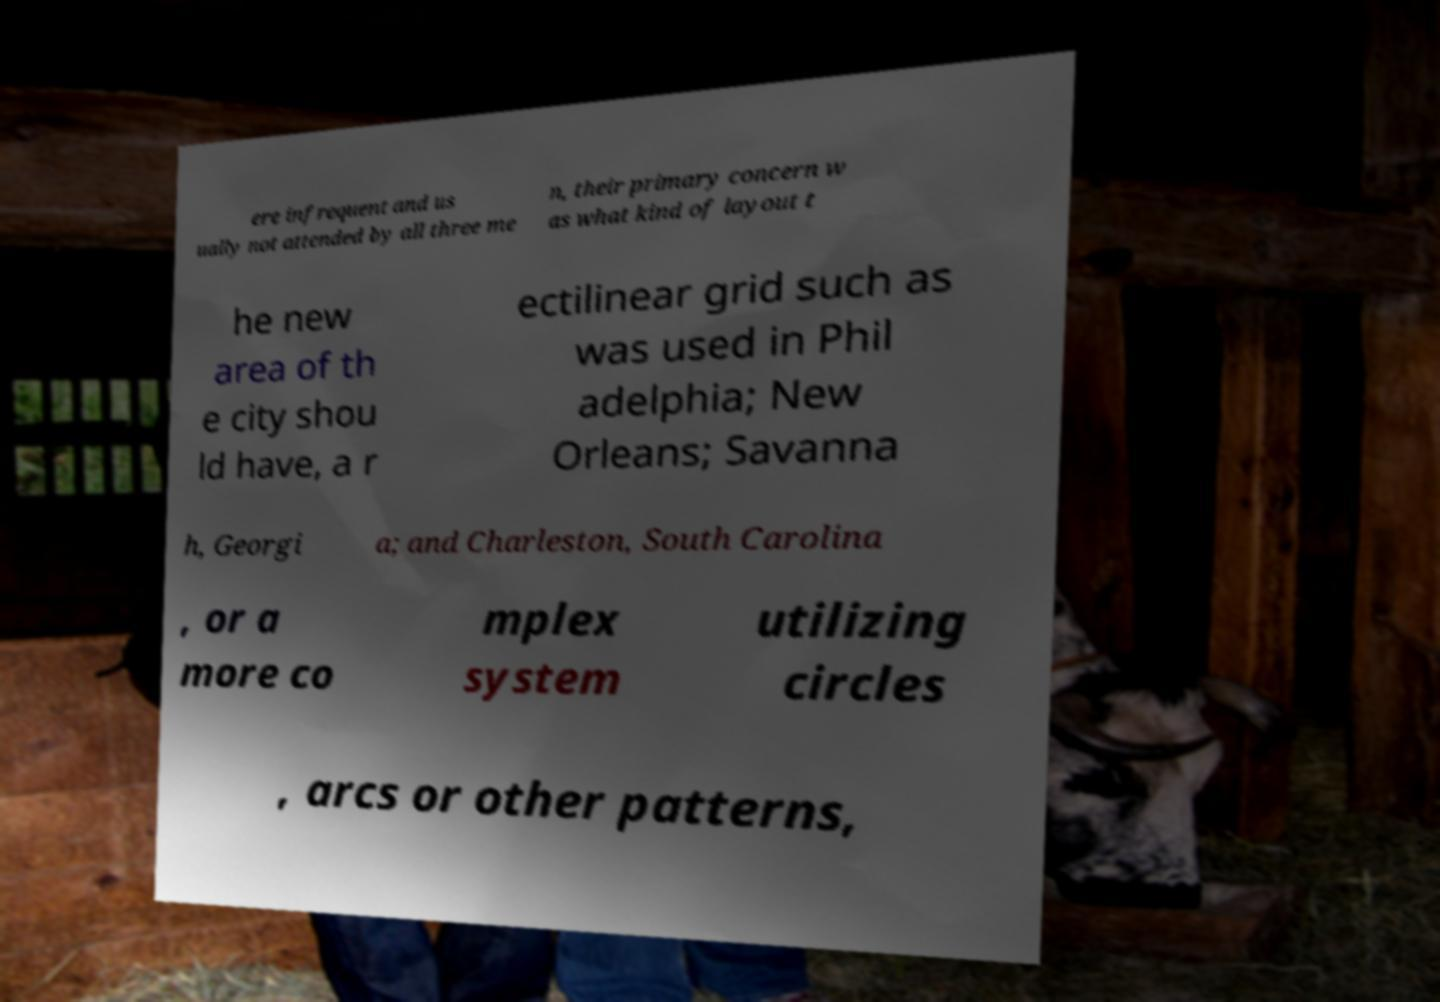Can you accurately transcribe the text from the provided image for me? ere infrequent and us ually not attended by all three me n, their primary concern w as what kind of layout t he new area of th e city shou ld have, a r ectilinear grid such as was used in Phil adelphia; New Orleans; Savanna h, Georgi a; and Charleston, South Carolina , or a more co mplex system utilizing circles , arcs or other patterns, 